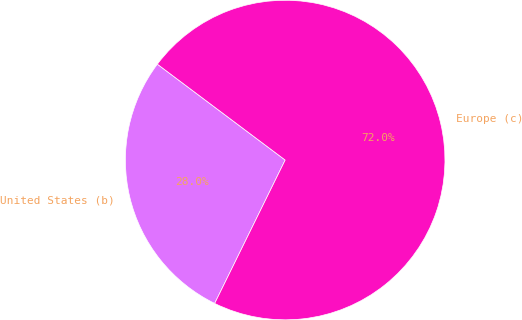<chart> <loc_0><loc_0><loc_500><loc_500><pie_chart><fcel>United States (b)<fcel>Europe (c)<nl><fcel>27.97%<fcel>72.03%<nl></chart> 